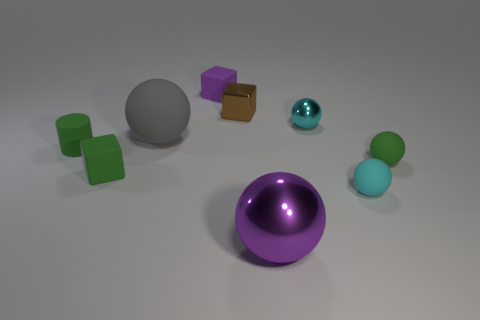Subtract 2 balls. How many balls are left? 3 Subtract all green balls. How many balls are left? 4 Subtract all small metal spheres. How many spheres are left? 4 Subtract all yellow spheres. Subtract all purple cylinders. How many spheres are left? 5 Add 1 big gray matte objects. How many objects exist? 10 Subtract all cubes. How many objects are left? 6 Subtract 0 cyan cylinders. How many objects are left? 9 Subtract all green rubber cubes. Subtract all purple metal objects. How many objects are left? 7 Add 7 tiny metal objects. How many tiny metal objects are left? 9 Add 4 small cyan spheres. How many small cyan spheres exist? 6 